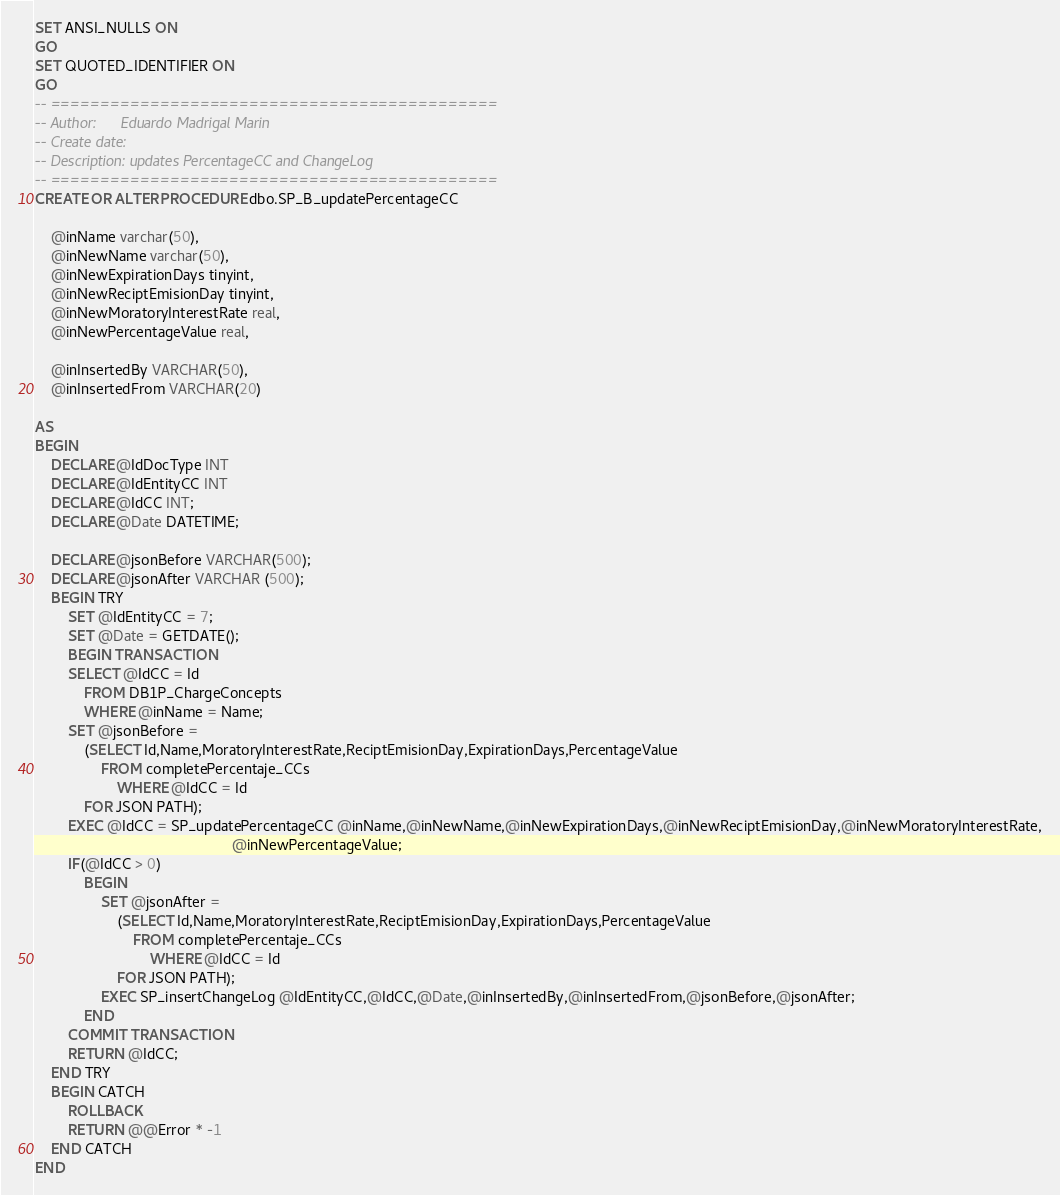<code> <loc_0><loc_0><loc_500><loc_500><_SQL_>SET ANSI_NULLS ON
GO
SET QUOTED_IDENTIFIER ON
GO
-- =============================================
-- Author:		Eduardo Madrigal Marin
-- Create date: 
-- Description:	updates PercentageCC and ChangeLog
-- =============================================
CREATE OR ALTER PROCEDURE dbo.SP_B_updatePercentageCC
	
	@inName varchar(50),
	@inNewName varchar(50),
	@inNewExpirationDays tinyint,
	@inNewReciptEmisionDay tinyint,
	@inNewMoratoryInterestRate real,
    @inNewPercentageValue real,

    @inInsertedBy VARCHAR(50),
    @inInsertedFrom VARCHAR(20)

AS
BEGIN
	DECLARE @IdDocType INT
    DECLARE @IdEntityCC INT
    DECLARE @IdCC INT;
    DECLARE @Date DATETIME;

    DECLARE @jsonBefore VARCHAR(500);
    DECLARE @jsonAfter VARCHAR (500);
	BEGIN TRY
        SET @IdEntityCC = 7;
        SET @Date = GETDATE();
        BEGIN TRANSACTION
        SELECT @IdCC = Id 
            FROM DB1P_ChargeConcepts
            WHERE @inName = Name;
        SET @jsonBefore = 
            (SELECT Id,Name,MoratoryInterestRate,ReciptEmisionDay,ExpirationDays,PercentageValue
				FROM completePercentaje_CCs
                    WHERE @IdCC = Id
            FOR JSON PATH);
        EXEC @IdCC = SP_updatePercentageCC @inName,@inNewName,@inNewExpirationDays,@inNewReciptEmisionDay,@inNewMoratoryInterestRate,
                                            	@inNewPercentageValue;
        IF(@IdCC > 0)
            BEGIN
                SET @jsonAfter = 
                    (SELECT Id,Name,MoratoryInterestRate,ReciptEmisionDay,ExpirationDays,PercentageValue
                        FROM completePercentaje_CCs
                            WHERE @IdCC = Id
                    FOR JSON PATH);
                EXEC SP_insertChangeLog @IdEntityCC,@IdCC,@Date,@inInsertedBy,@inInsertedFrom,@jsonBefore,@jsonAfter;
            END
        COMMIT TRANSACTION
        RETURN @IdCC;
	END TRY
	BEGIN CATCH
        ROLLBACK
		RETURN @@Error * -1
	END CATCH		
END</code> 